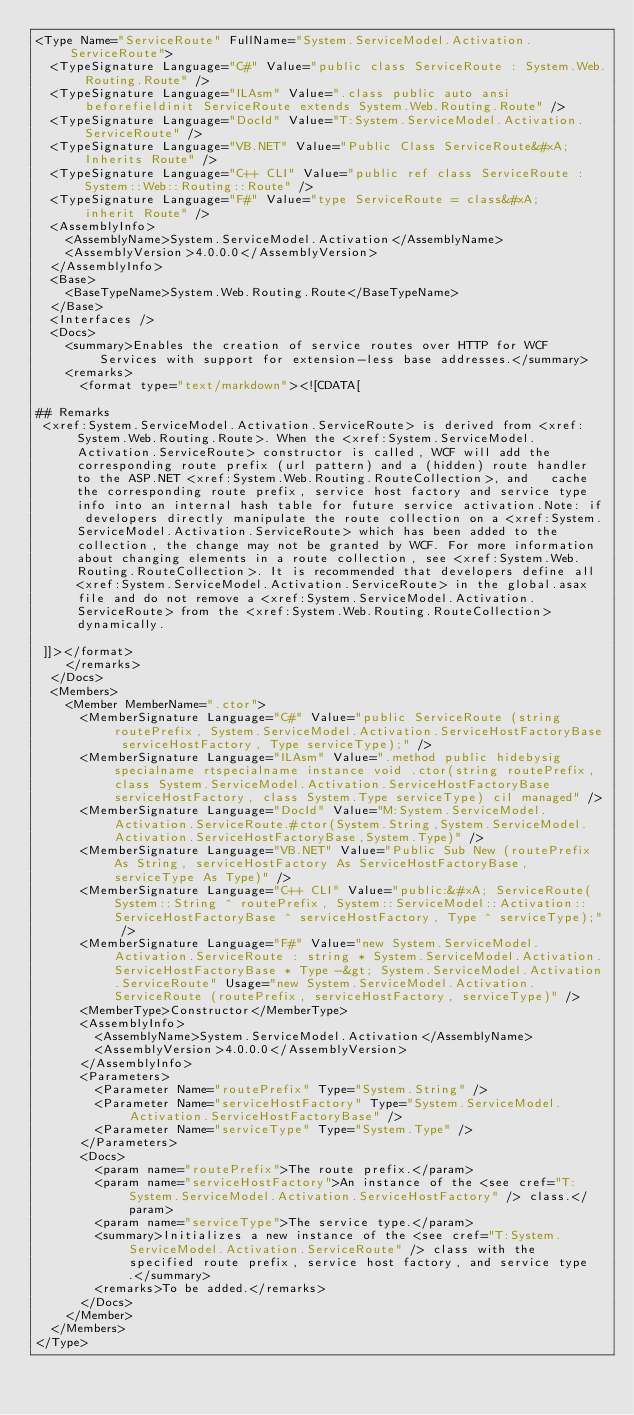<code> <loc_0><loc_0><loc_500><loc_500><_XML_><Type Name="ServiceRoute" FullName="System.ServiceModel.Activation.ServiceRoute">
  <TypeSignature Language="C#" Value="public class ServiceRoute : System.Web.Routing.Route" />
  <TypeSignature Language="ILAsm" Value=".class public auto ansi beforefieldinit ServiceRoute extends System.Web.Routing.Route" />
  <TypeSignature Language="DocId" Value="T:System.ServiceModel.Activation.ServiceRoute" />
  <TypeSignature Language="VB.NET" Value="Public Class ServiceRoute&#xA;Inherits Route" />
  <TypeSignature Language="C++ CLI" Value="public ref class ServiceRoute : System::Web::Routing::Route" />
  <TypeSignature Language="F#" Value="type ServiceRoute = class&#xA;    inherit Route" />
  <AssemblyInfo>
    <AssemblyName>System.ServiceModel.Activation</AssemblyName>
    <AssemblyVersion>4.0.0.0</AssemblyVersion>
  </AssemblyInfo>
  <Base>
    <BaseTypeName>System.Web.Routing.Route</BaseTypeName>
  </Base>
  <Interfaces />
  <Docs>
    <summary>Enables the creation of service routes over HTTP for WCF Services with support for extension-less base addresses.</summary>
    <remarks>
      <format type="text/markdown"><![CDATA[  
  
## Remarks  
 <xref:System.ServiceModel.Activation.ServiceRoute> is derived from <xref:System.Web.Routing.Route>. When the <xref:System.ServiceModel.Activation.ServiceRoute> constructor is called, WCF will add the corresponding route prefix (url pattern) and a (hidden) route handler to the ASP.NET <xref:System.Web.Routing.RouteCollection>, and   cache the corresponding route prefix, service host factory and service type info into an internal hash table for future service activation.Note: if developers directly manipulate the route collection on a <xref:System.ServiceModel.Activation.ServiceRoute> which has been added to the collection, the change may not be granted by WCF. For more information about changing elements in a route collection, see <xref:System.Web.Routing.RouteCollection>. It is recommended that developers define all <xref:System.ServiceModel.Activation.ServiceRoute> in the global.asax file and do not remove a <xref:System.ServiceModel.Activation.ServiceRoute> from the <xref:System.Web.Routing.RouteCollection> dynamically.  
  
 ]]></format>
    </remarks>
  </Docs>
  <Members>
    <Member MemberName=".ctor">
      <MemberSignature Language="C#" Value="public ServiceRoute (string routePrefix, System.ServiceModel.Activation.ServiceHostFactoryBase serviceHostFactory, Type serviceType);" />
      <MemberSignature Language="ILAsm" Value=".method public hidebysig specialname rtspecialname instance void .ctor(string routePrefix, class System.ServiceModel.Activation.ServiceHostFactoryBase serviceHostFactory, class System.Type serviceType) cil managed" />
      <MemberSignature Language="DocId" Value="M:System.ServiceModel.Activation.ServiceRoute.#ctor(System.String,System.ServiceModel.Activation.ServiceHostFactoryBase,System.Type)" />
      <MemberSignature Language="VB.NET" Value="Public Sub New (routePrefix As String, serviceHostFactory As ServiceHostFactoryBase, serviceType As Type)" />
      <MemberSignature Language="C++ CLI" Value="public:&#xA; ServiceRoute(System::String ^ routePrefix, System::ServiceModel::Activation::ServiceHostFactoryBase ^ serviceHostFactory, Type ^ serviceType);" />
      <MemberSignature Language="F#" Value="new System.ServiceModel.Activation.ServiceRoute : string * System.ServiceModel.Activation.ServiceHostFactoryBase * Type -&gt; System.ServiceModel.Activation.ServiceRoute" Usage="new System.ServiceModel.Activation.ServiceRoute (routePrefix, serviceHostFactory, serviceType)" />
      <MemberType>Constructor</MemberType>
      <AssemblyInfo>
        <AssemblyName>System.ServiceModel.Activation</AssemblyName>
        <AssemblyVersion>4.0.0.0</AssemblyVersion>
      </AssemblyInfo>
      <Parameters>
        <Parameter Name="routePrefix" Type="System.String" />
        <Parameter Name="serviceHostFactory" Type="System.ServiceModel.Activation.ServiceHostFactoryBase" />
        <Parameter Name="serviceType" Type="System.Type" />
      </Parameters>
      <Docs>
        <param name="routePrefix">The route prefix.</param>
        <param name="serviceHostFactory">An instance of the <see cref="T:System.ServiceModel.Activation.ServiceHostFactory" /> class.</param>
        <param name="serviceType">The service type.</param>
        <summary>Initializes a new instance of the <see cref="T:System.ServiceModel.Activation.ServiceRoute" /> class with the specified route prefix, service host factory, and service type.</summary>
        <remarks>To be added.</remarks>
      </Docs>
    </Member>
  </Members>
</Type>
</code> 